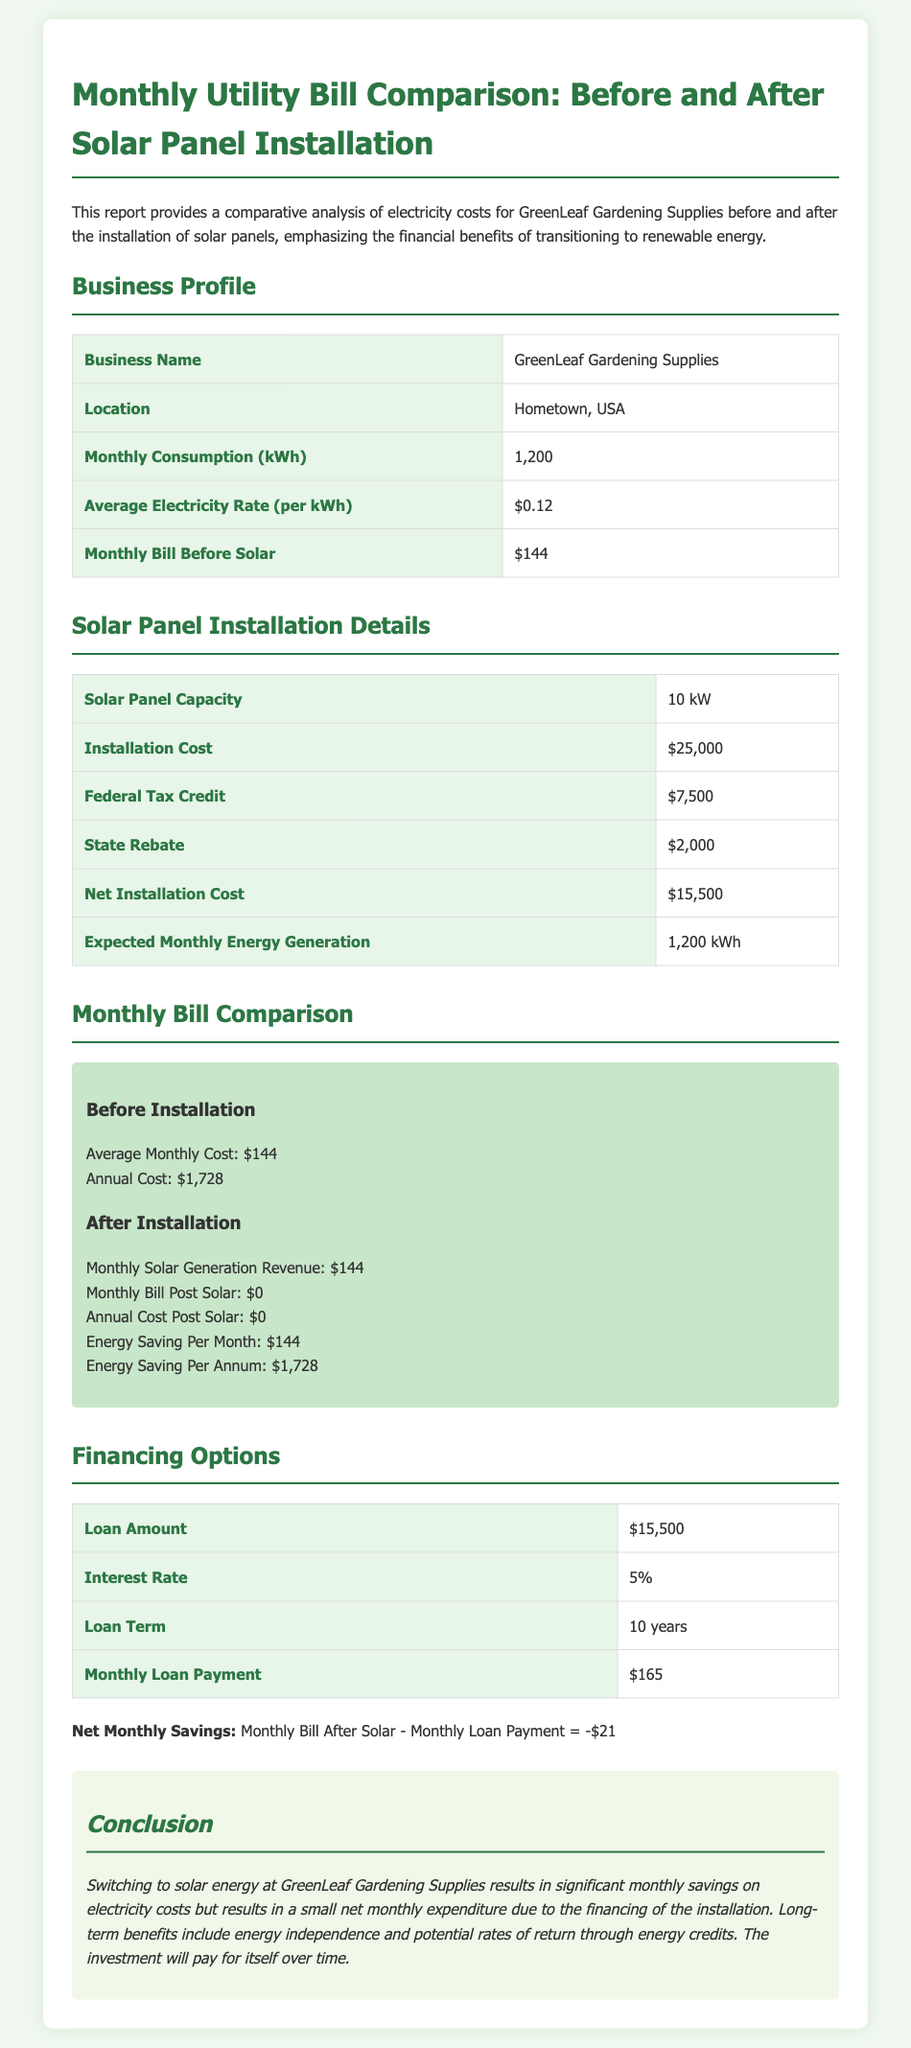what is the business name? The business name mentioned in the document is GreenLeaf Gardening Supplies.
Answer: GreenLeaf Gardening Supplies what is the monthly consumption in kWh? The monthly consumption mentioned in the report is 1,200 kWh.
Answer: 1,200 kWh what was the installation cost of the solar panels? The document states the installation cost is $25,000.
Answer: $25,000 what is the expected monthly energy generation? The expected monthly energy generation after installation is 1,200 kWh.
Answer: 1,200 kWh what are the energy savings per month after solar installation? The document indicates monthly energy savings after solar installation is $144.
Answer: $144 what is the net installation cost after tax credit and rebate? The net installation cost after tax credit and rebate is $15,500.
Answer: $15,500 what is the loan term mentioned in the financing options? The loan term specified in the document is 10 years.
Answer: 10 years what is the monthly loan payment? The monthly loan payment for financing the solar panel installation is $165.
Answer: $165 what is the annual cost post solar installation? The document states the annual cost post solar installation is $0.
Answer: $0 